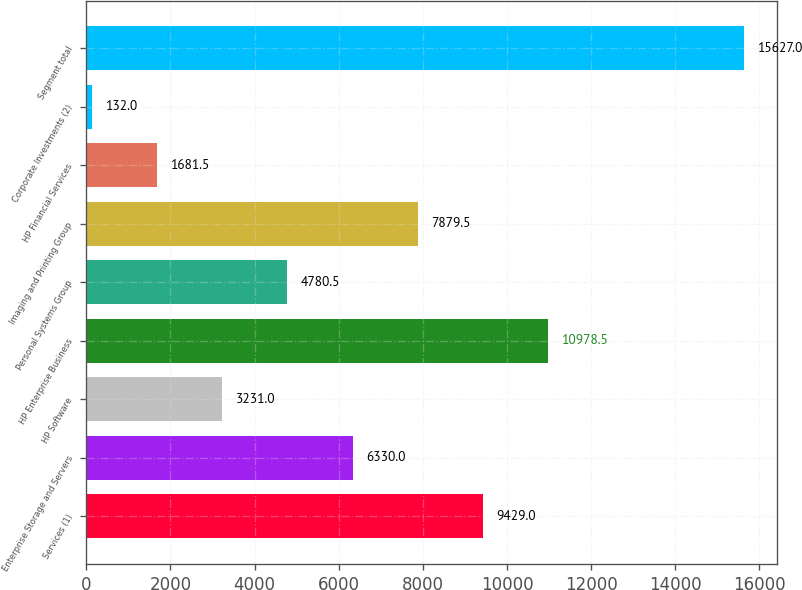<chart> <loc_0><loc_0><loc_500><loc_500><bar_chart><fcel>Services (1)<fcel>Enterprise Storage and Servers<fcel>HP Software<fcel>HP Enterprise Business<fcel>Personal Systems Group<fcel>Imaging and Printing Group<fcel>HP Financial Services<fcel>Corporate Investments (2)<fcel>Segment total<nl><fcel>9429<fcel>6330<fcel>3231<fcel>10978.5<fcel>4780.5<fcel>7879.5<fcel>1681.5<fcel>132<fcel>15627<nl></chart> 